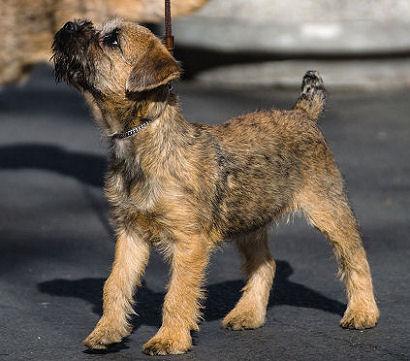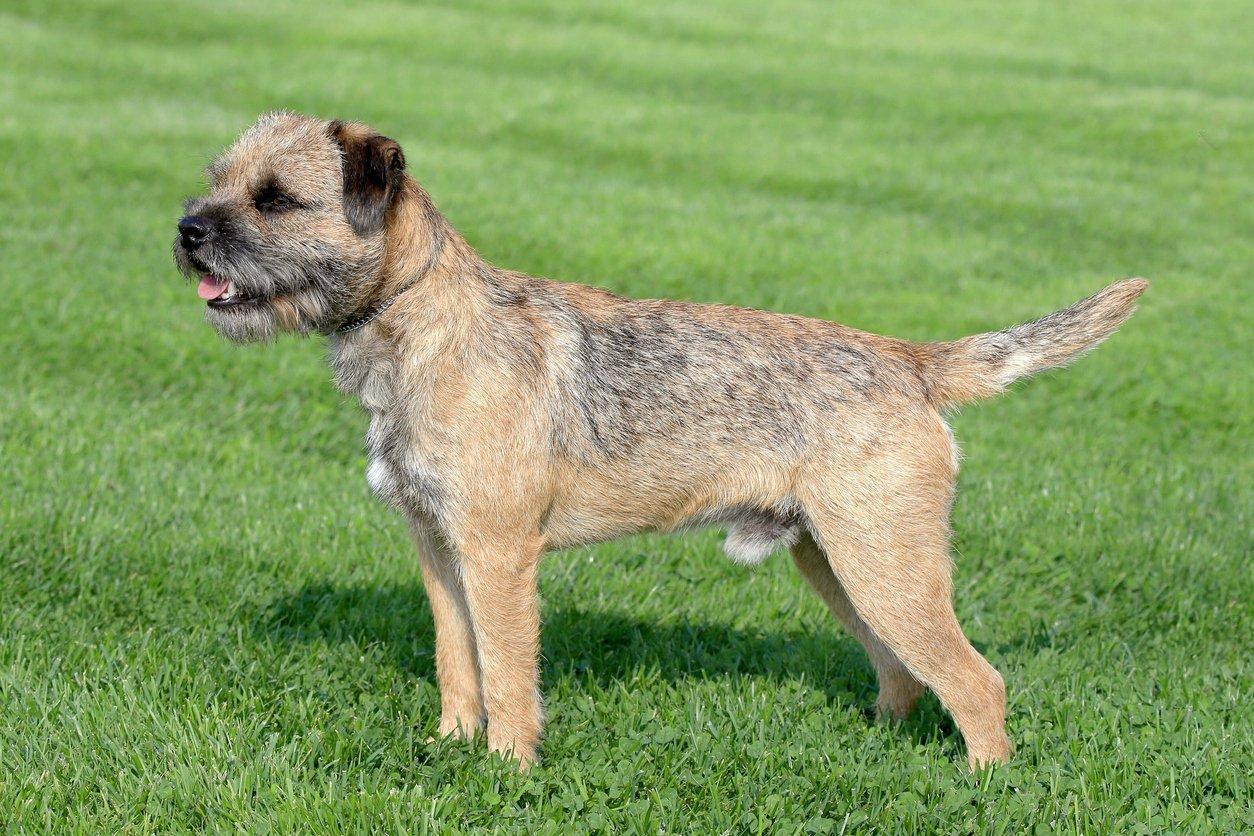The first image is the image on the left, the second image is the image on the right. Considering the images on both sides, is "In one image a dog is in the grass, moving forward with its left leg higher than the right and has its mouth open." valid? Answer yes or no. No. The first image is the image on the left, the second image is the image on the right. Given the left and right images, does the statement "The left and right image contains the same number of dogs facing the same directions." hold true? Answer yes or no. Yes. 